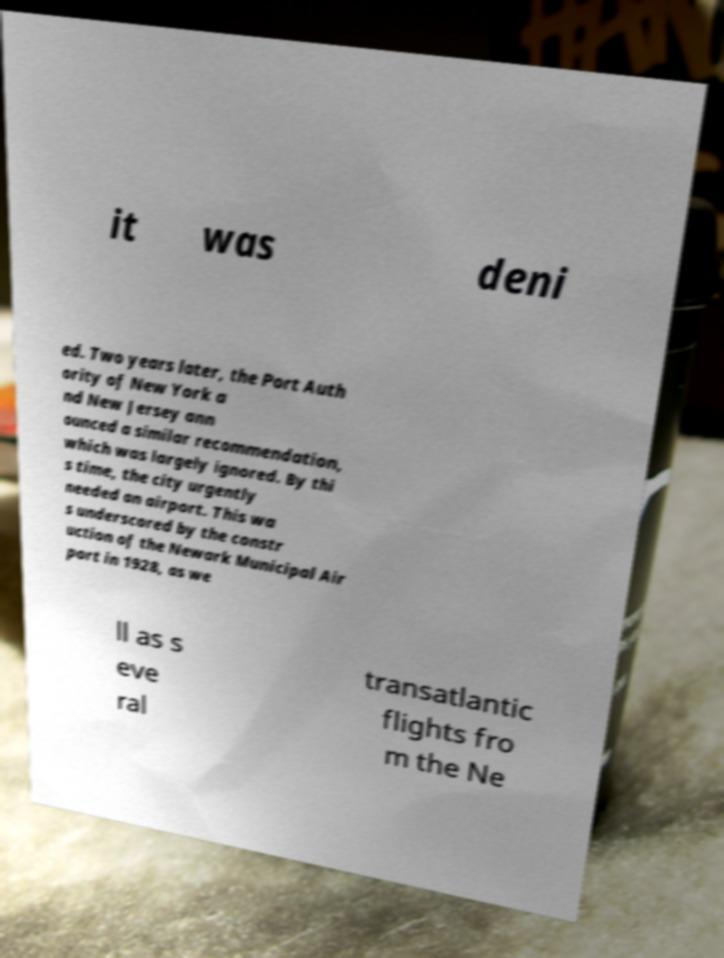What messages or text are displayed in this image? I need them in a readable, typed format. it was deni ed. Two years later, the Port Auth ority of New York a nd New Jersey ann ounced a similar recommendation, which was largely ignored. By thi s time, the city urgently needed an airport. This wa s underscored by the constr uction of the Newark Municipal Air port in 1928, as we ll as s eve ral transatlantic flights fro m the Ne 